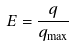<formula> <loc_0><loc_0><loc_500><loc_500>E = \frac { q } { q _ { \max } }</formula> 